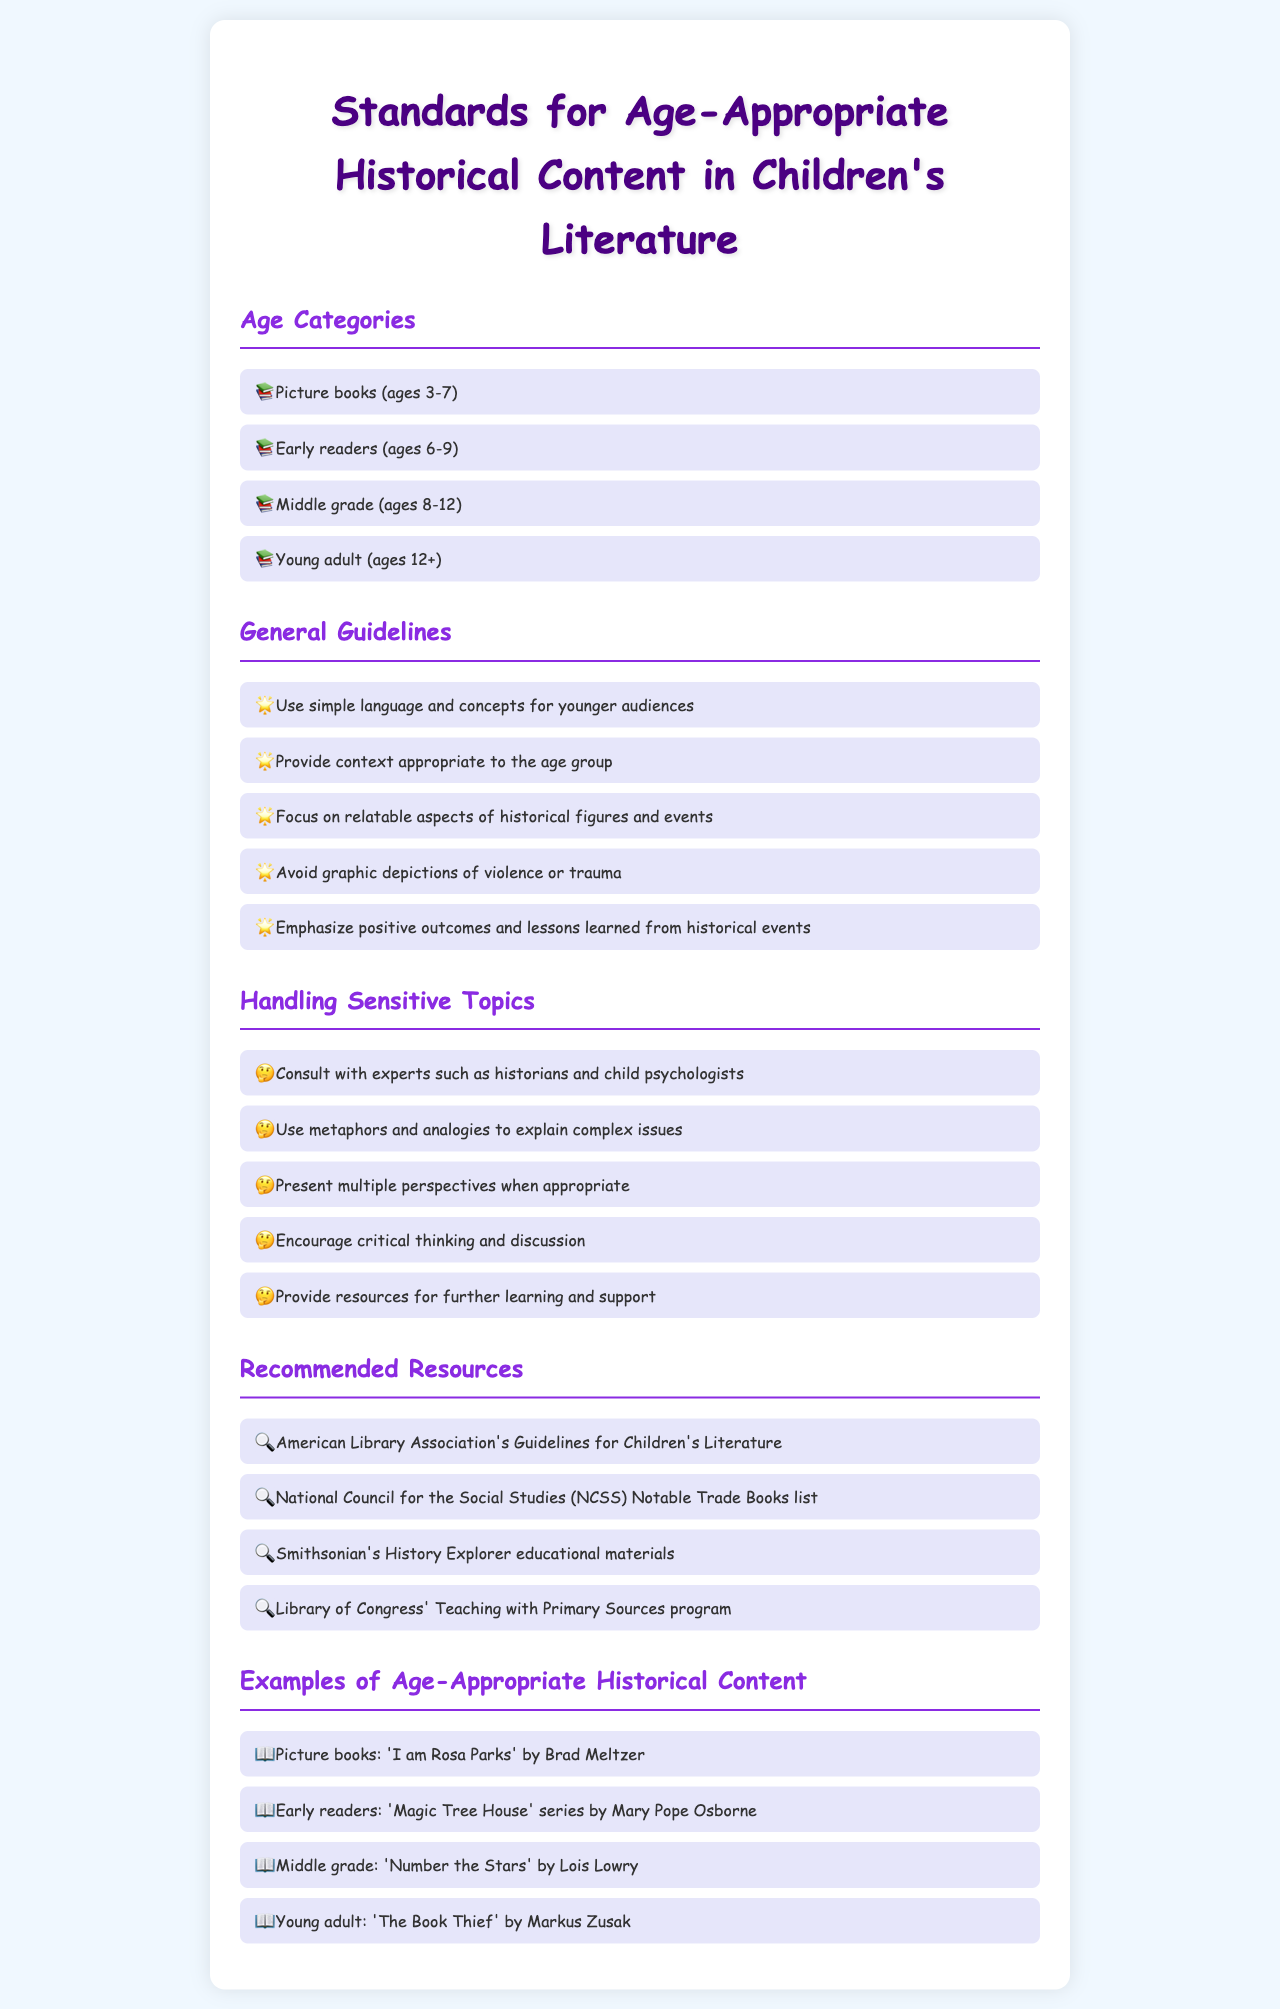What are the age categories for children's literature? The age categories include Picture books, Early readers, Middle grade, and Young adult as mentioned in the document.
Answer: Picture books, Early readers, Middle grade, Young adult What is the maximum age for the middle grade category? The middle grade category is specified for children ages 8-12, which provides a clear upper limit.
Answer: 12 What is a guideline for presenting historical content to younger audiences? The document states that one guideline is to use simple language and concepts for younger audiences to aid understanding.
Answer: Use simple language and concepts How should sensitive topics be handled according to the document? The guidelines suggest consulting with experts such as historians and child psychologists when addressing sensitive topics effectively.
Answer: Consult with experts Which book is an example of a middle-grade historical content? The document provides the title 'Number the Stars' by Lois Lowry as an example in the middle-grade category.
Answer: Number the Stars What does the document recommend to support further learning? The document includes several resources for further learning, specifically mentioning several organizations and their contributions to historical education.
Answer: Provide resources for further learning What metaphorical technique should be used to explain complex issues? The document mentions using metaphors and analogies as a technique for explaining complex issues in an age-appropriate manner.
Answer: Use metaphors and analogies Which organization is mentioned as a resource for children's literature guidelines? The document specifies the American Library Association as a resource for guidelines related to children's literature.
Answer: American Library Association 